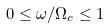Convert formula to latex. <formula><loc_0><loc_0><loc_500><loc_500>0 \leq \omega / \Omega _ { c } \leq 1</formula> 